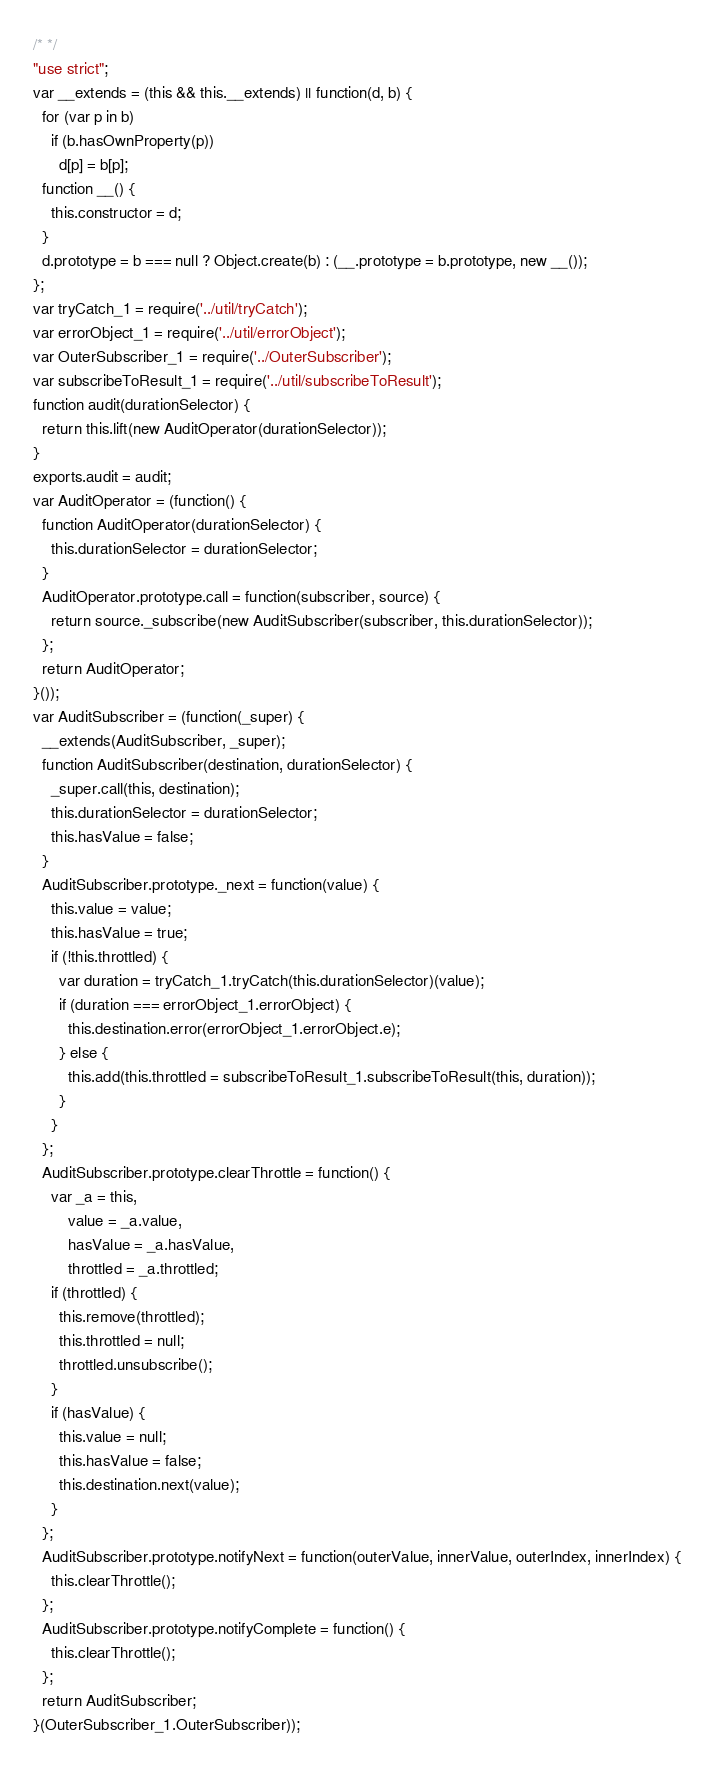Convert code to text. <code><loc_0><loc_0><loc_500><loc_500><_JavaScript_>/* */ 
"use strict";
var __extends = (this && this.__extends) || function(d, b) {
  for (var p in b)
    if (b.hasOwnProperty(p))
      d[p] = b[p];
  function __() {
    this.constructor = d;
  }
  d.prototype = b === null ? Object.create(b) : (__.prototype = b.prototype, new __());
};
var tryCatch_1 = require('../util/tryCatch');
var errorObject_1 = require('../util/errorObject');
var OuterSubscriber_1 = require('../OuterSubscriber');
var subscribeToResult_1 = require('../util/subscribeToResult');
function audit(durationSelector) {
  return this.lift(new AuditOperator(durationSelector));
}
exports.audit = audit;
var AuditOperator = (function() {
  function AuditOperator(durationSelector) {
    this.durationSelector = durationSelector;
  }
  AuditOperator.prototype.call = function(subscriber, source) {
    return source._subscribe(new AuditSubscriber(subscriber, this.durationSelector));
  };
  return AuditOperator;
}());
var AuditSubscriber = (function(_super) {
  __extends(AuditSubscriber, _super);
  function AuditSubscriber(destination, durationSelector) {
    _super.call(this, destination);
    this.durationSelector = durationSelector;
    this.hasValue = false;
  }
  AuditSubscriber.prototype._next = function(value) {
    this.value = value;
    this.hasValue = true;
    if (!this.throttled) {
      var duration = tryCatch_1.tryCatch(this.durationSelector)(value);
      if (duration === errorObject_1.errorObject) {
        this.destination.error(errorObject_1.errorObject.e);
      } else {
        this.add(this.throttled = subscribeToResult_1.subscribeToResult(this, duration));
      }
    }
  };
  AuditSubscriber.prototype.clearThrottle = function() {
    var _a = this,
        value = _a.value,
        hasValue = _a.hasValue,
        throttled = _a.throttled;
    if (throttled) {
      this.remove(throttled);
      this.throttled = null;
      throttled.unsubscribe();
    }
    if (hasValue) {
      this.value = null;
      this.hasValue = false;
      this.destination.next(value);
    }
  };
  AuditSubscriber.prototype.notifyNext = function(outerValue, innerValue, outerIndex, innerIndex) {
    this.clearThrottle();
  };
  AuditSubscriber.prototype.notifyComplete = function() {
    this.clearThrottle();
  };
  return AuditSubscriber;
}(OuterSubscriber_1.OuterSubscriber));
</code> 